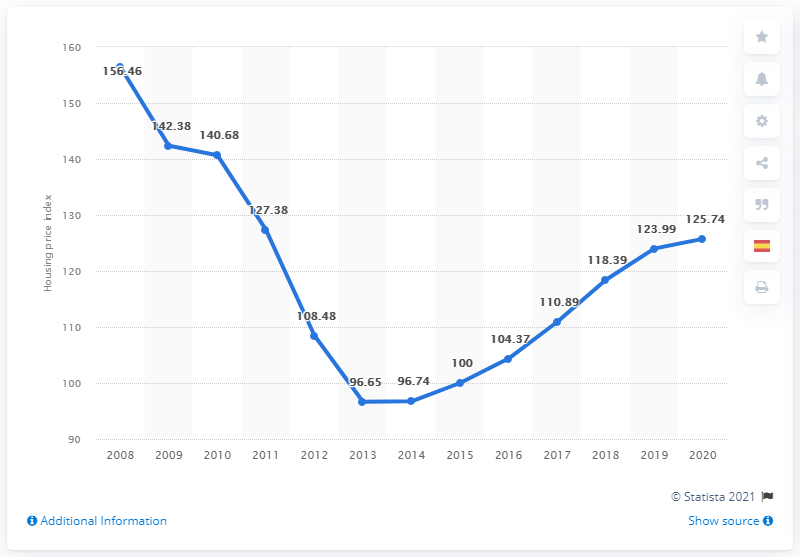Draw attention to some important aspects in this diagram. In 2015, the Spanish house price index began to increase. 